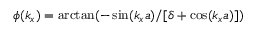<formula> <loc_0><loc_0><loc_500><loc_500>\phi ( k _ { x } ) = \arctan ( - \sin ( k _ { x } a ) / [ \delta + \cos ( k _ { x } a ) ] )</formula> 